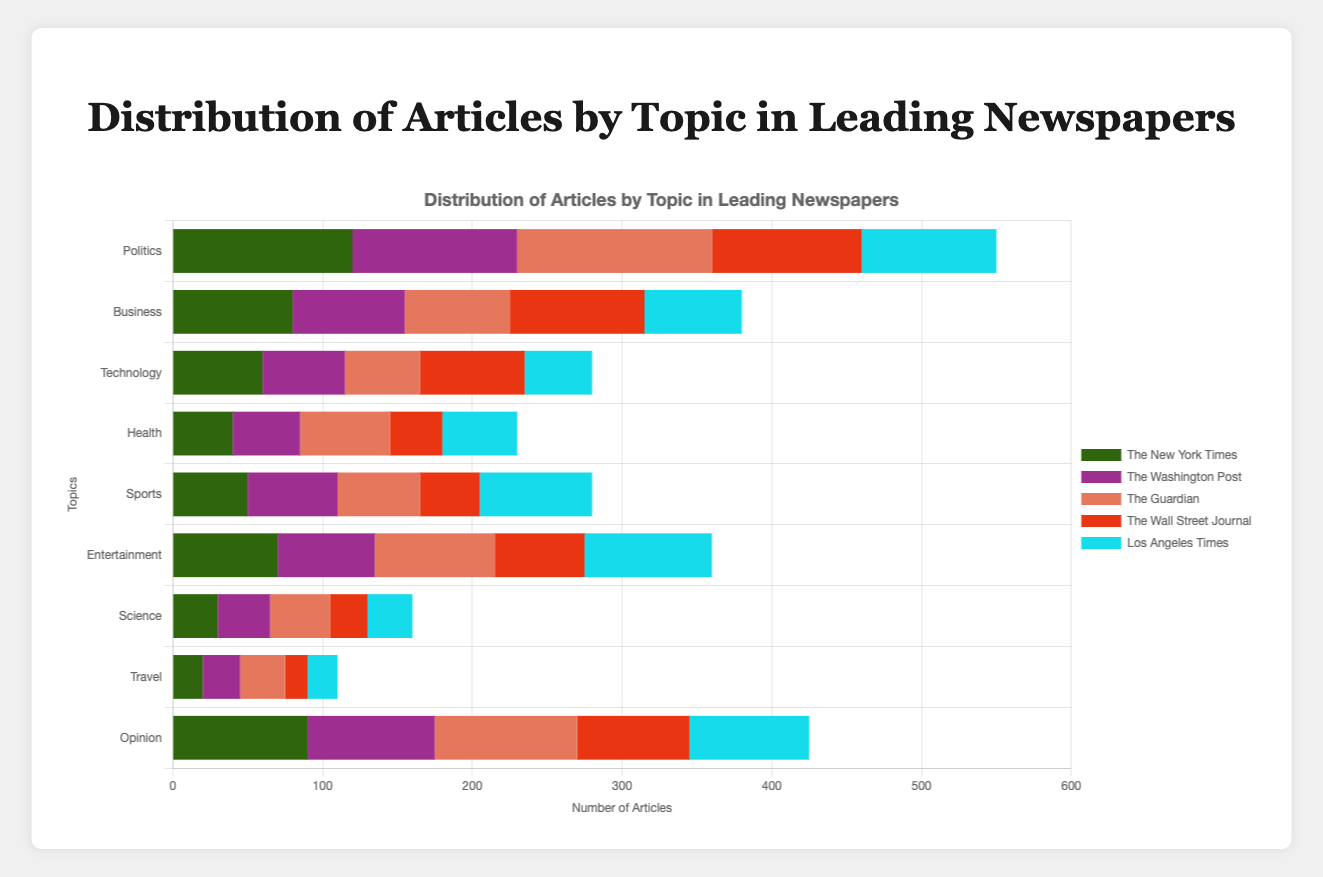Which newspaper has the highest number of Politics articles? To identify the newspaper with the highest number of Politics articles, look at the length of the bars corresponding to the Politics topic across all newspapers. The Guardian has the longest bar in this category.
Answer: The Guardian Which topic has the least number of articles in The Wall Street Journal? Investigate the bars representing The Wall Street Journal's articles. The Travel bar is the shortest, indicating the least number of articles.
Answer: Travel Compare the number of Technology articles between The New York Times and The Washington Post. Which has more and by how much? Look at the Technology bars for The New York Times and The Washington Post. The New York Times has 60 articles, and The Washington Post has 55. The difference is 60 - 55 = 5 articles.
Answer: The New York Times, 5 articles What is the total number of Business articles across all newspapers? Sum the Business articles for all the newspapers: 80 (NYT) + 75 (WP) + 70 (Guardian) + 90 (WSJ) + 65 (LAT) = 380 articles.
Answer: 380 Which topic is the most covered in the Los Angeles Times and how does it compare to the most covered topic in The New York Times? Find the longest bar for each newspaper: Entertainment for the Los Angeles Times (85) and Politics for The New York Times (120). Politics is more covered.
Answer: Politics, 35 more articles What is the combined number of articles related to Health and Sports for The Guardian? Add the number of Health and Sports articles for The Guardian, which is 60 (Health) + 55 (Sports) = 115.
Answer: 115 How many more Opinion articles are written by The Guardian compared to The Washington Post? Look at the Opinion articles for both; The Guardian has 95 and The Washington Post has 85. The difference is 95 - 85 = 10 articles.
Answer: 10 articles Which newspaper has the smallest range in the number of articles across all topics? Calculate the range (max - min) of the number of articles for each newspaper and compare: The New York Times (120 - 20 = 100), The Washington Post (110 - 25 = 85), The Guardian (130 - 30 = 100), The Wall Street Journal (100 - 15 = 85), and Los Angeles Times (90 - 20 = 65). The Los Angeles Times has the smallest range.
Answer: Los Angeles Times Compare the number of Science articles between The Washington Post and The New York Times and identify the one with fewer articles. Look at the Science articles for both; The Washington Post has 35 and The New York Times has 30. The New York Times has fewer articles.
Answer: The New York Times Calculate the average number of Entertainment articles across all newspapers. Sum Entertainment articles for all: 70 (NYT) + 65 (WP) + 80 (Guardian) + 60 (WSJ) + 85 (LAT) = 360. There are 5 newspapers, so the average is 360 / 5 = 72.
Answer: 72 